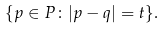Convert formula to latex. <formula><loc_0><loc_0><loc_500><loc_500>\{ p \in P \colon | p - q | = t \} .</formula> 